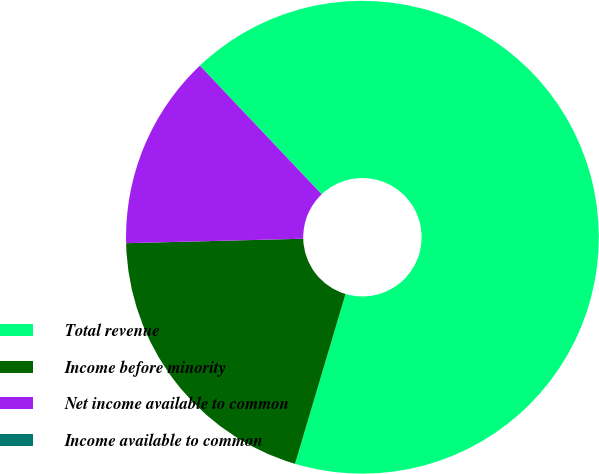Convert chart to OTSL. <chart><loc_0><loc_0><loc_500><loc_500><pie_chart><fcel>Total revenue<fcel>Income before minority<fcel>Net income available to common<fcel>Income available to common<nl><fcel>66.67%<fcel>20.0%<fcel>13.33%<fcel>0.0%<nl></chart> 